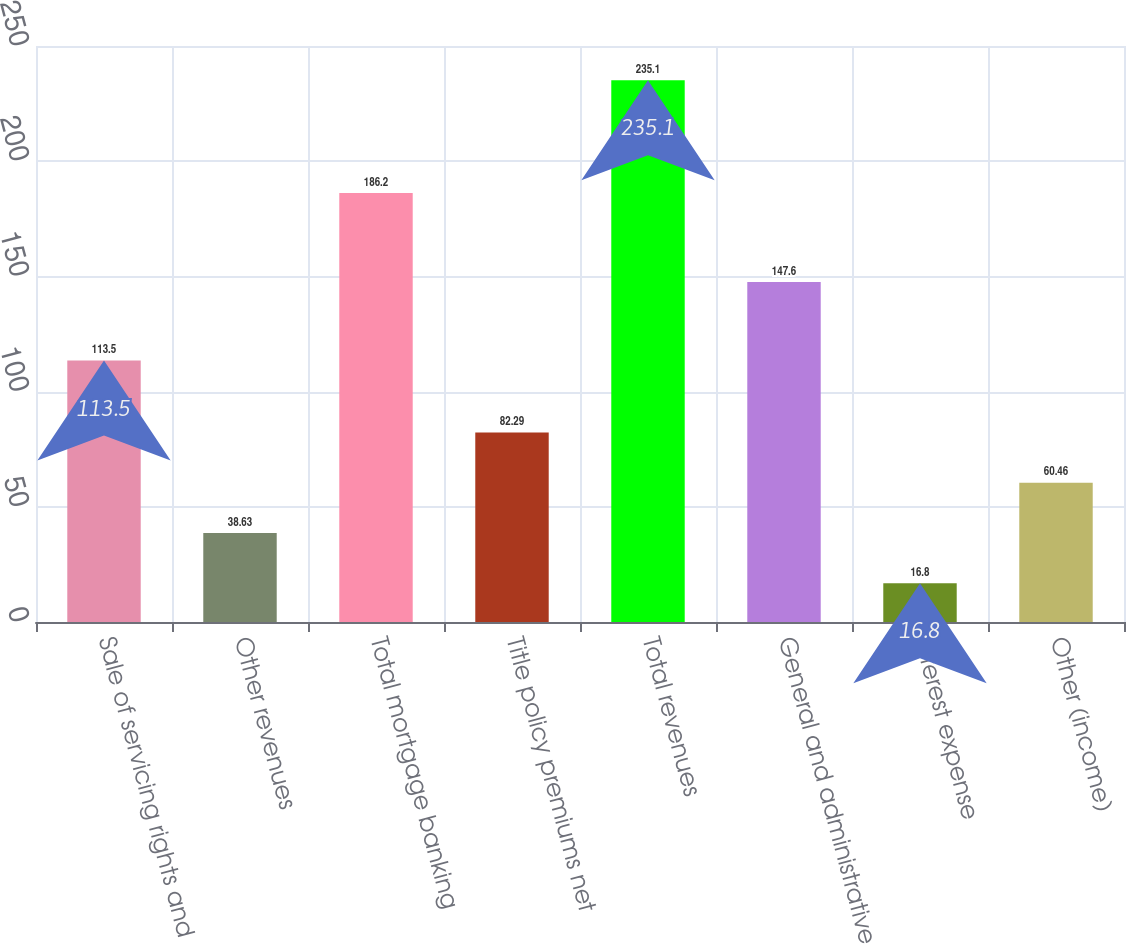Convert chart. <chart><loc_0><loc_0><loc_500><loc_500><bar_chart><fcel>Sale of servicing rights and<fcel>Other revenues<fcel>Total mortgage banking<fcel>Title policy premiums net<fcel>Total revenues<fcel>General and administrative<fcel>Interest expense<fcel>Other (income)<nl><fcel>113.5<fcel>38.63<fcel>186.2<fcel>82.29<fcel>235.1<fcel>147.6<fcel>16.8<fcel>60.46<nl></chart> 